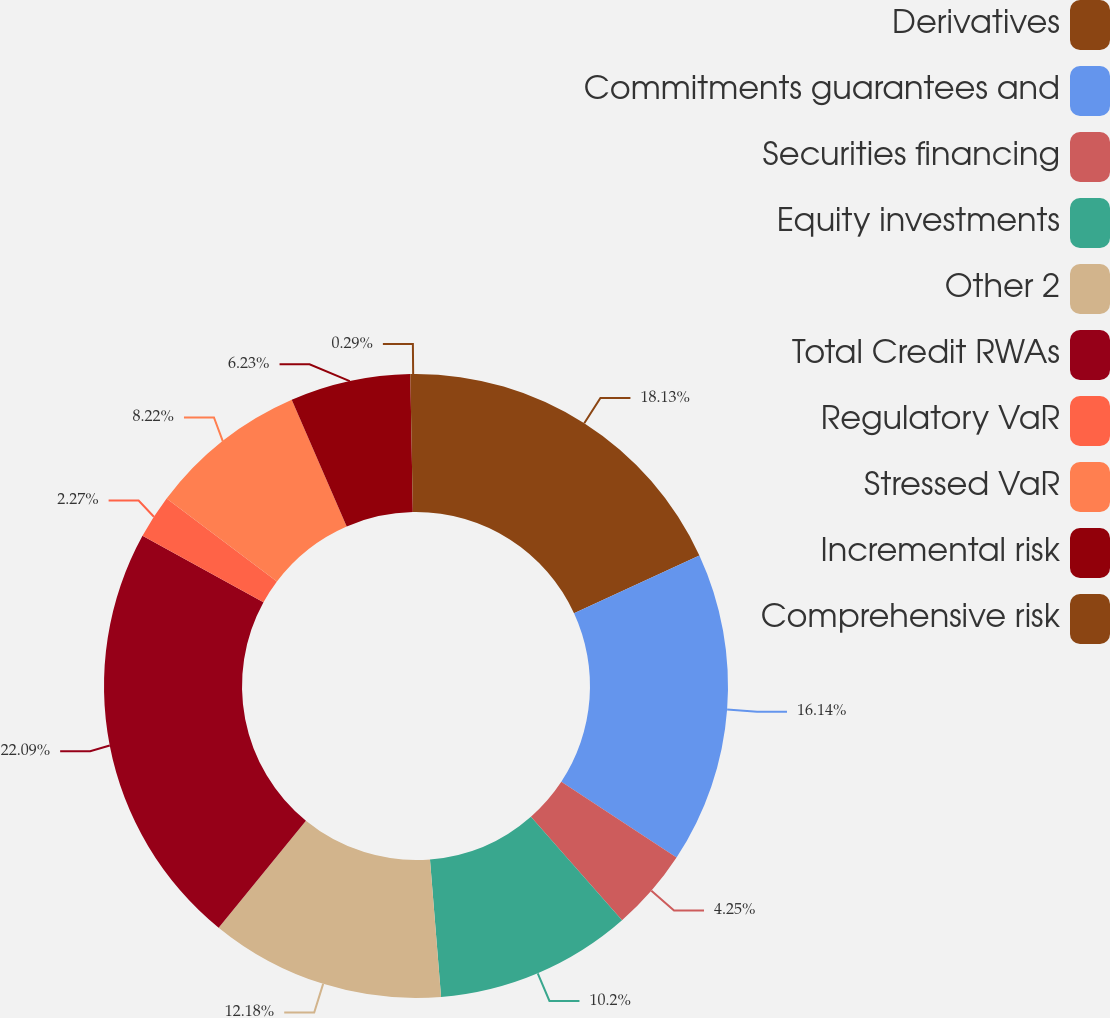Convert chart to OTSL. <chart><loc_0><loc_0><loc_500><loc_500><pie_chart><fcel>Derivatives<fcel>Commitments guarantees and<fcel>Securities financing<fcel>Equity investments<fcel>Other 2<fcel>Total Credit RWAs<fcel>Regulatory VaR<fcel>Stressed VaR<fcel>Incremental risk<fcel>Comprehensive risk<nl><fcel>18.13%<fcel>16.14%<fcel>4.25%<fcel>10.2%<fcel>12.18%<fcel>22.09%<fcel>2.27%<fcel>8.22%<fcel>6.23%<fcel>0.29%<nl></chart> 